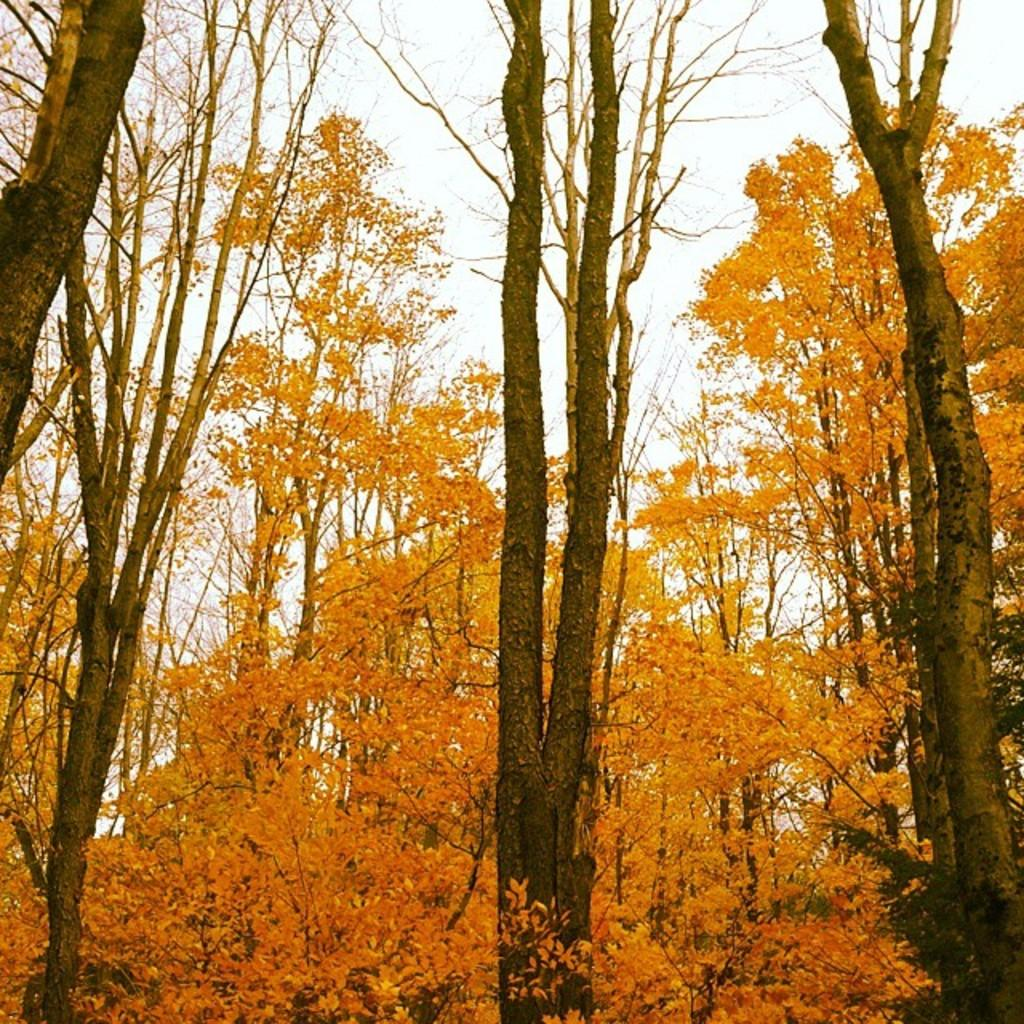What type of vegetation can be seen in the image? There are trees in the image. What is visible in the background of the image? The sky is visible in the background of the image. Can you tell me which channel the maid is watching on the TV in the image? A: There is no TV or maid present in the image; it only features trees and the sky. 